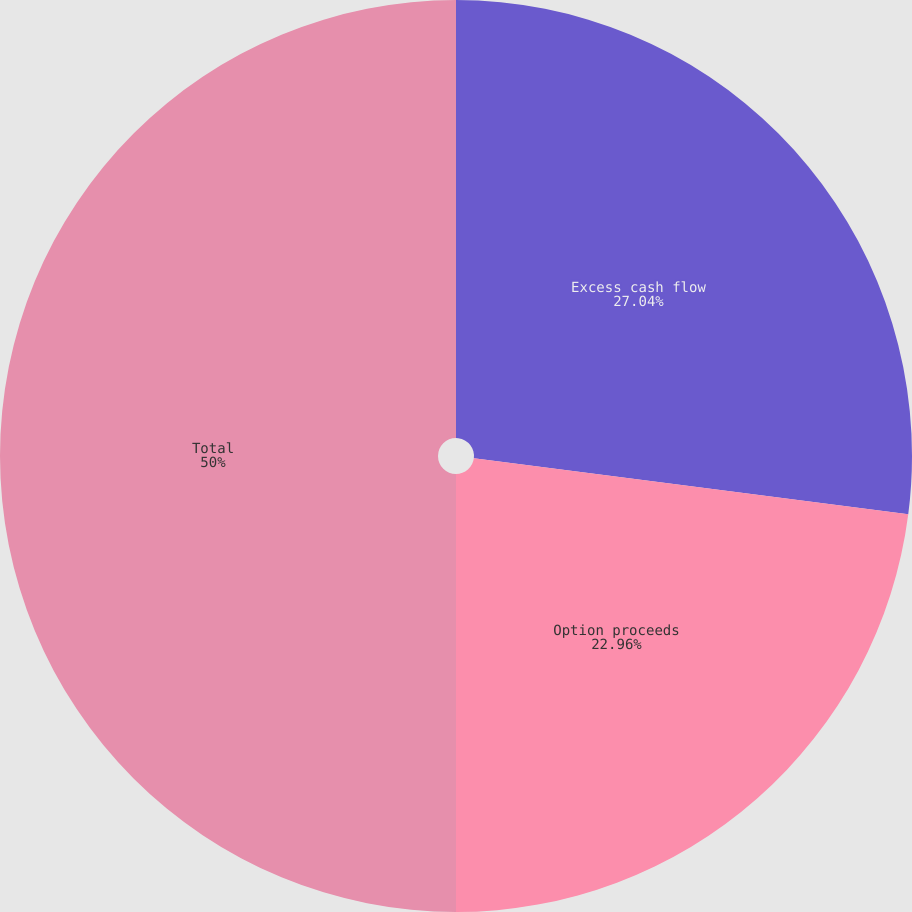<chart> <loc_0><loc_0><loc_500><loc_500><pie_chart><fcel>Excess cash flow<fcel>Option proceeds<fcel>Total<nl><fcel>27.04%<fcel>22.96%<fcel>50.0%<nl></chart> 